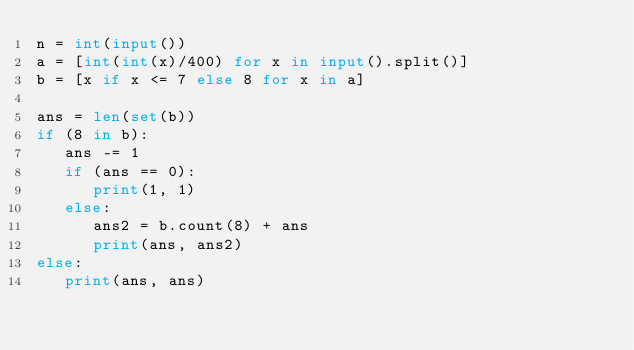<code> <loc_0><loc_0><loc_500><loc_500><_Python_>n = int(input())
a = [int(int(x)/400) for x in input().split()]
b = [x if x <= 7 else 8 for x in a]

ans = len(set(b))
if (8 in b):
   ans -= 1
   if (ans == 0):
      print(1, 1)
   else:
      ans2 = b.count(8) + ans
      print(ans, ans2)
else:
   print(ans, ans)
</code> 